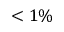<formula> <loc_0><loc_0><loc_500><loc_500>< 1 \%</formula> 